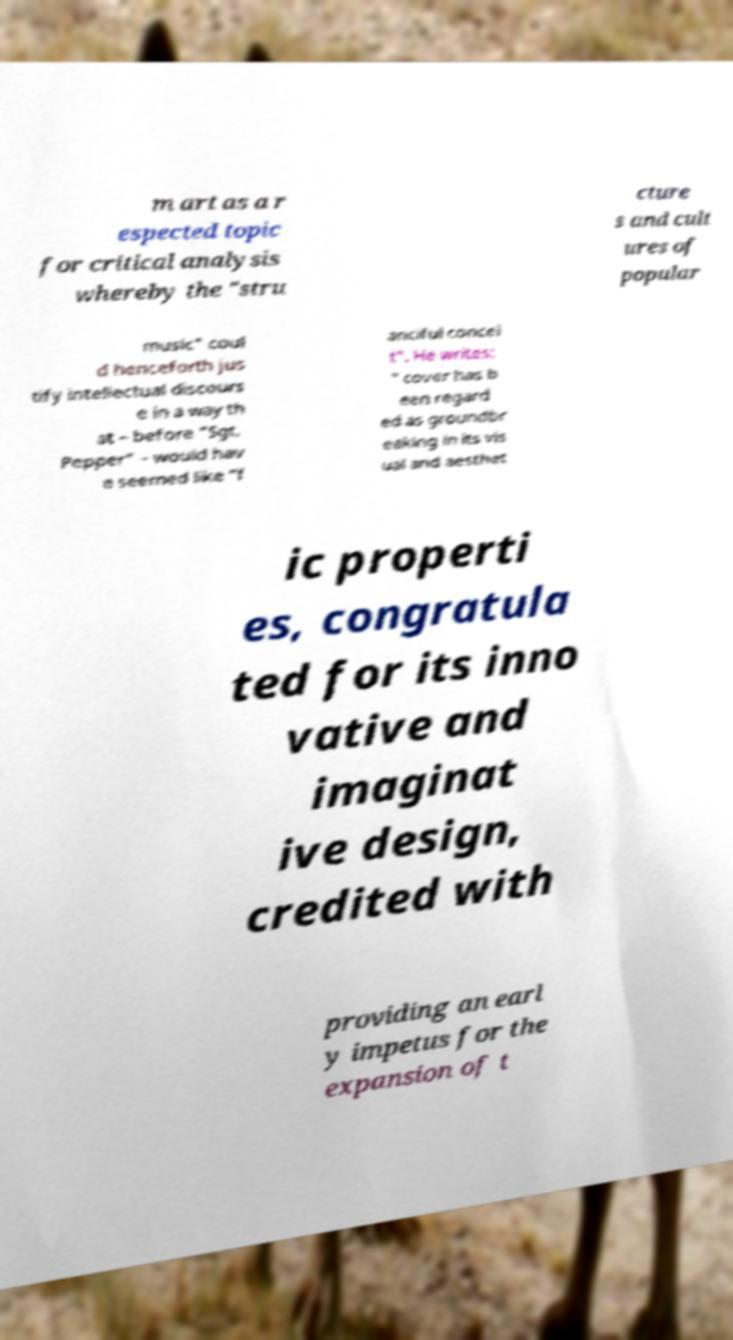What messages or text are displayed in this image? I need them in a readable, typed format. m art as a r espected topic for critical analysis whereby the "stru cture s and cult ures of popular music" coul d henceforth jus tify intellectual discours e in a way th at – before "Sgt. Pepper" – would hav e seemed like "f anciful concei t". He writes: " cover has b een regard ed as groundbr eaking in its vis ual and aesthet ic properti es, congratula ted for its inno vative and imaginat ive design, credited with providing an earl y impetus for the expansion of t 